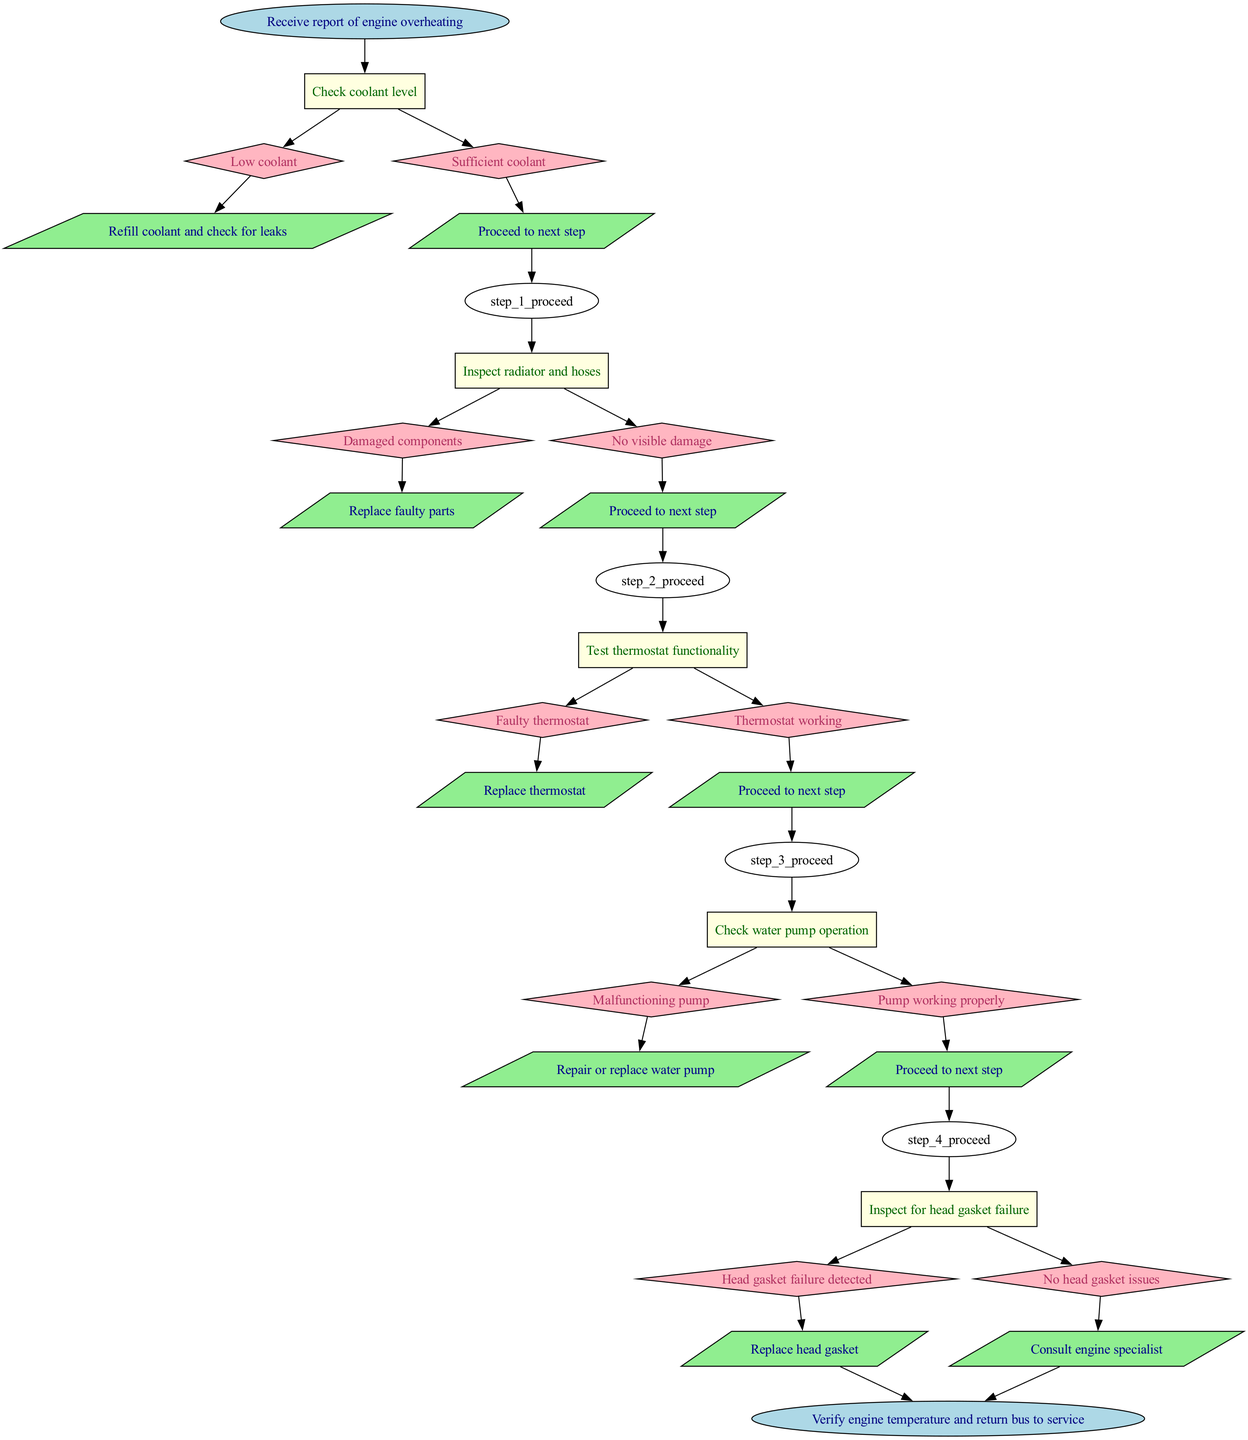What is the first step in the procedure? The first step in the procedure, indicated in the flow chart, is "Check coolant level." This is shown as the first rectangular node directly connected to the start node.
Answer: Check coolant level How many steps are there in the diagram? The diagram contains a total of five steps, which are sequentially numbered from one to five, as represented by the respective rectangular nodes in the flow chart.
Answer: 5 What action is taken if there's low coolant? If the coolant level is low, the action taken is to "Refill coolant and check for leaks," as indicated in the options connected to the first step in the flow chart.
Answer: Refill coolant and check for leaks Which step follows after "Test thermostat functionality"? After "Test thermostat functionality," the next step is "Check water pump operation," as shown by the connection to the subsequent rectangular node in the flow chart.
Answer: Check water pump operation What happens if a faulty thermostat is discovered? If a faulty thermostat is discovered, the action taken is to "Replace thermostat," which is specified in the options related to the thermostat functionality test step in the diagram.
Answer: Replace thermostat What is the final node in the diagram? The final node in the diagram is "Verify engine temperature and return bus to service," which is shown as the end node connected to the last action performed in the flow chart.
Answer: Verify engine temperature and return bus to service If there is no head gasket failure detected, what should be done? If no head gasket failure is detected, the instruction is to "Consult engine specialist," which is outlined in the options of the fifth step in the flow chart.
Answer: Consult engine specialist How are damaged radiator components addressed? Damaged radiator components are addressed by the action "Replace faulty parts," which is indicated in the second step of the diagram when inspecting radiator and hoses.
Answer: Replace faulty parts 